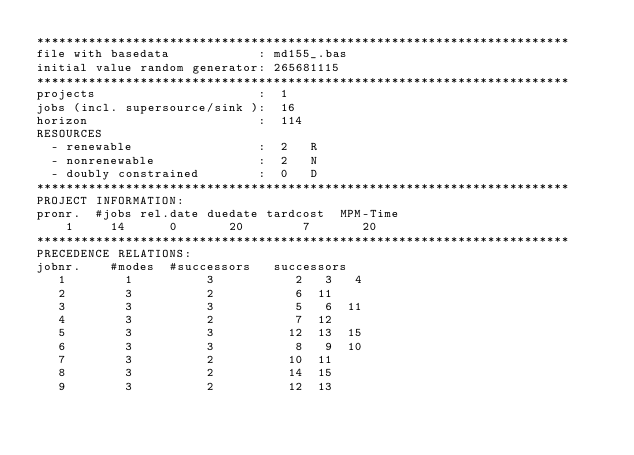<code> <loc_0><loc_0><loc_500><loc_500><_ObjectiveC_>************************************************************************
file with basedata            : md155_.bas
initial value random generator: 265681115
************************************************************************
projects                      :  1
jobs (incl. supersource/sink ):  16
horizon                       :  114
RESOURCES
  - renewable                 :  2   R
  - nonrenewable              :  2   N
  - doubly constrained        :  0   D
************************************************************************
PROJECT INFORMATION:
pronr.  #jobs rel.date duedate tardcost  MPM-Time
    1     14      0       20        7       20
************************************************************************
PRECEDENCE RELATIONS:
jobnr.    #modes  #successors   successors
   1        1          3           2   3   4
   2        3          2           6  11
   3        3          3           5   6  11
   4        3          2           7  12
   5        3          3          12  13  15
   6        3          3           8   9  10
   7        3          2          10  11
   8        3          2          14  15
   9        3          2          12  13</code> 